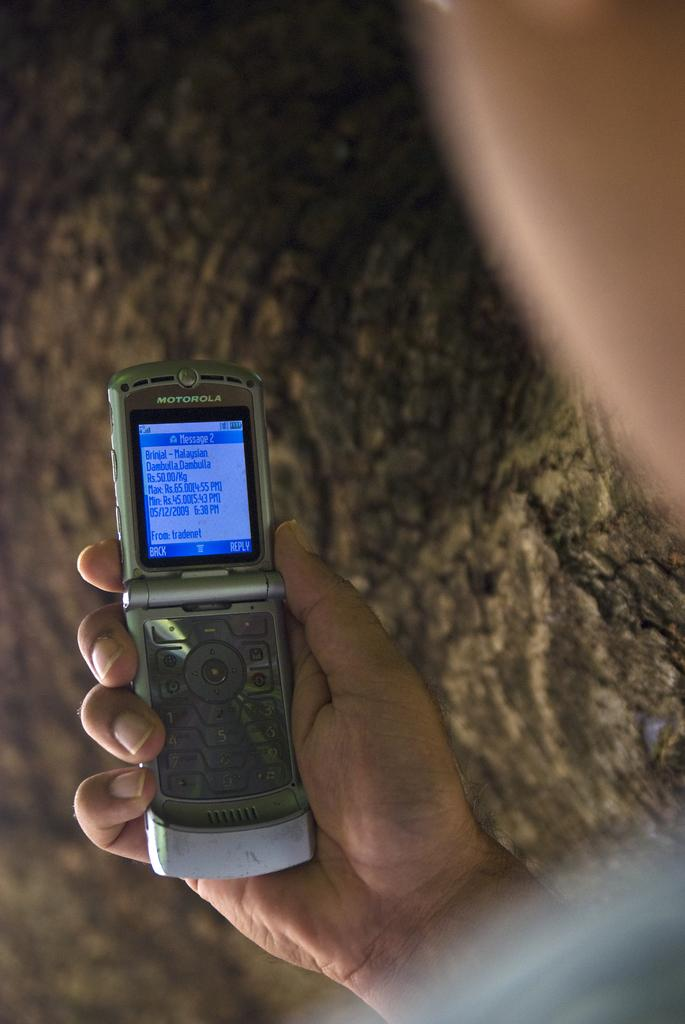What can be seen in the background of the image? There is a tree in the background of the image. Where is the man located in the image? The man is on the right side of the image. What is the man holding in his hand? The man is holding a mobile phone in his hand. What is visible on the mobile phone screen? There is text visible on the mobile phone screen. Is the man trying to escape from quicksand in the image? There is no quicksand present in the image, and the man is not depicted as trying to escape from anything. What type of shoe is the man wearing in the image? The image does not show the man's shoes, so it is not possible to determine what type of shoe he is wearing. 